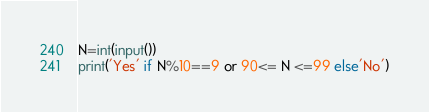Convert code to text. <code><loc_0><loc_0><loc_500><loc_500><_Python_>N=int(input())
print('Yes' if N%10==9 or 90<= N <=99 else'No')
</code> 